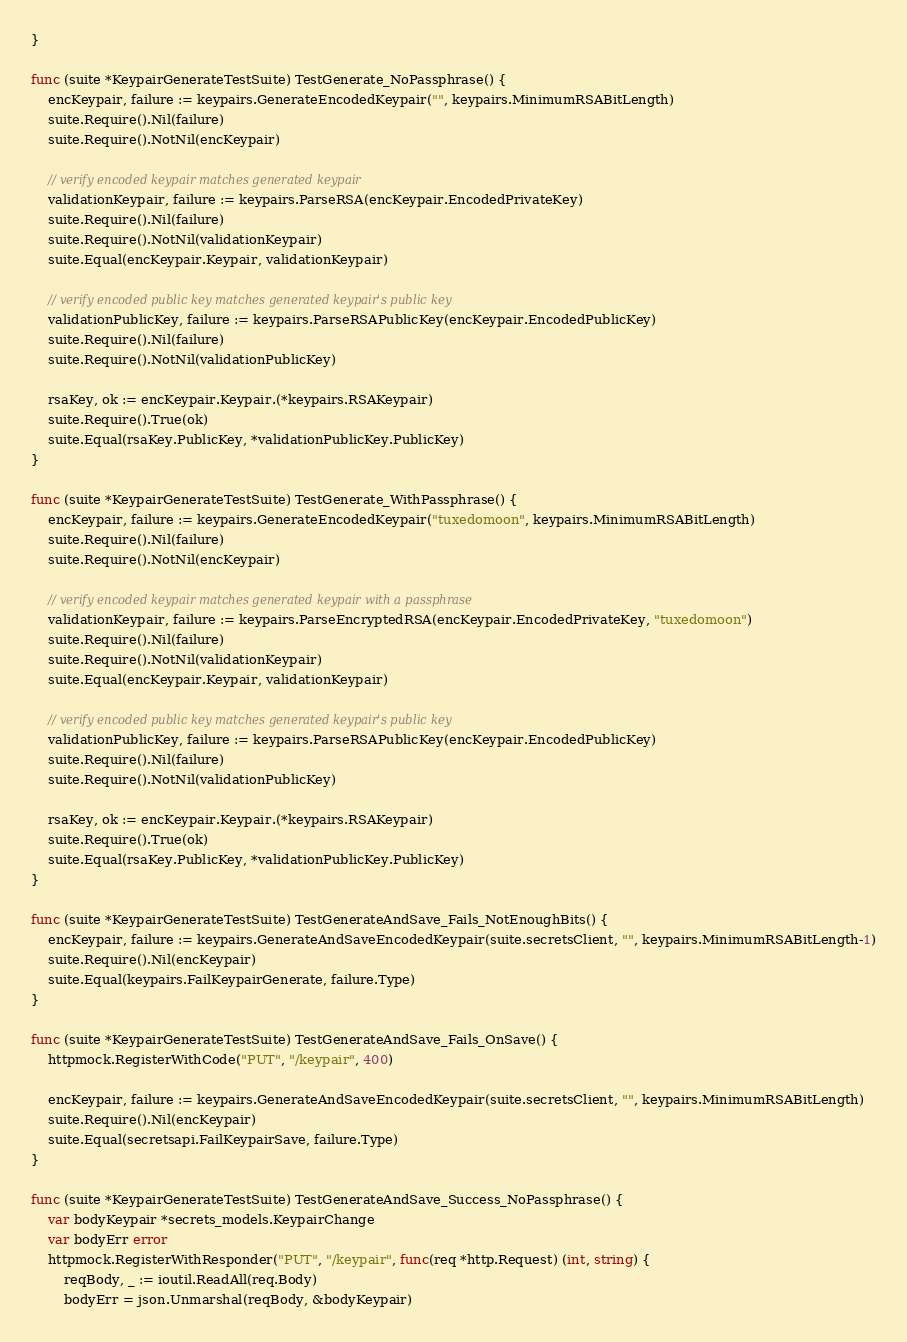<code> <loc_0><loc_0><loc_500><loc_500><_Go_>}

func (suite *KeypairGenerateTestSuite) TestGenerate_NoPassphrase() {
	encKeypair, failure := keypairs.GenerateEncodedKeypair("", keypairs.MinimumRSABitLength)
	suite.Require().Nil(failure)
	suite.Require().NotNil(encKeypair)

	// verify encoded keypair matches generated keypair
	validationKeypair, failure := keypairs.ParseRSA(encKeypair.EncodedPrivateKey)
	suite.Require().Nil(failure)
	suite.Require().NotNil(validationKeypair)
	suite.Equal(encKeypair.Keypair, validationKeypair)

	// verify encoded public key matches generated keypair's public key
	validationPublicKey, failure := keypairs.ParseRSAPublicKey(encKeypair.EncodedPublicKey)
	suite.Require().Nil(failure)
	suite.Require().NotNil(validationPublicKey)

	rsaKey, ok := encKeypair.Keypair.(*keypairs.RSAKeypair)
	suite.Require().True(ok)
	suite.Equal(rsaKey.PublicKey, *validationPublicKey.PublicKey)
}

func (suite *KeypairGenerateTestSuite) TestGenerate_WithPassphrase() {
	encKeypair, failure := keypairs.GenerateEncodedKeypair("tuxedomoon", keypairs.MinimumRSABitLength)
	suite.Require().Nil(failure)
	suite.Require().NotNil(encKeypair)

	// verify encoded keypair matches generated keypair with a passphrase
	validationKeypair, failure := keypairs.ParseEncryptedRSA(encKeypair.EncodedPrivateKey, "tuxedomoon")
	suite.Require().Nil(failure)
	suite.Require().NotNil(validationKeypair)
	suite.Equal(encKeypair.Keypair, validationKeypair)

	// verify encoded public key matches generated keypair's public key
	validationPublicKey, failure := keypairs.ParseRSAPublicKey(encKeypair.EncodedPublicKey)
	suite.Require().Nil(failure)
	suite.Require().NotNil(validationPublicKey)

	rsaKey, ok := encKeypair.Keypair.(*keypairs.RSAKeypair)
	suite.Require().True(ok)
	suite.Equal(rsaKey.PublicKey, *validationPublicKey.PublicKey)
}

func (suite *KeypairGenerateTestSuite) TestGenerateAndSave_Fails_NotEnoughBits() {
	encKeypair, failure := keypairs.GenerateAndSaveEncodedKeypair(suite.secretsClient, "", keypairs.MinimumRSABitLength-1)
	suite.Require().Nil(encKeypair)
	suite.Equal(keypairs.FailKeypairGenerate, failure.Type)
}

func (suite *KeypairGenerateTestSuite) TestGenerateAndSave_Fails_OnSave() {
	httpmock.RegisterWithCode("PUT", "/keypair", 400)

	encKeypair, failure := keypairs.GenerateAndSaveEncodedKeypair(suite.secretsClient, "", keypairs.MinimumRSABitLength)
	suite.Require().Nil(encKeypair)
	suite.Equal(secretsapi.FailKeypairSave, failure.Type)
}

func (suite *KeypairGenerateTestSuite) TestGenerateAndSave_Success_NoPassphrase() {
	var bodyKeypair *secrets_models.KeypairChange
	var bodyErr error
	httpmock.RegisterWithResponder("PUT", "/keypair", func(req *http.Request) (int, string) {
		reqBody, _ := ioutil.ReadAll(req.Body)
		bodyErr = json.Unmarshal(reqBody, &bodyKeypair)</code> 